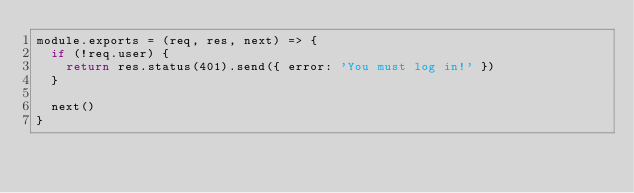Convert code to text. <code><loc_0><loc_0><loc_500><loc_500><_JavaScript_>module.exports = (req, res, next) => {
  if (!req.user) {
    return res.status(401).send({ error: 'You must log in!' })
  }

  next()
}
</code> 